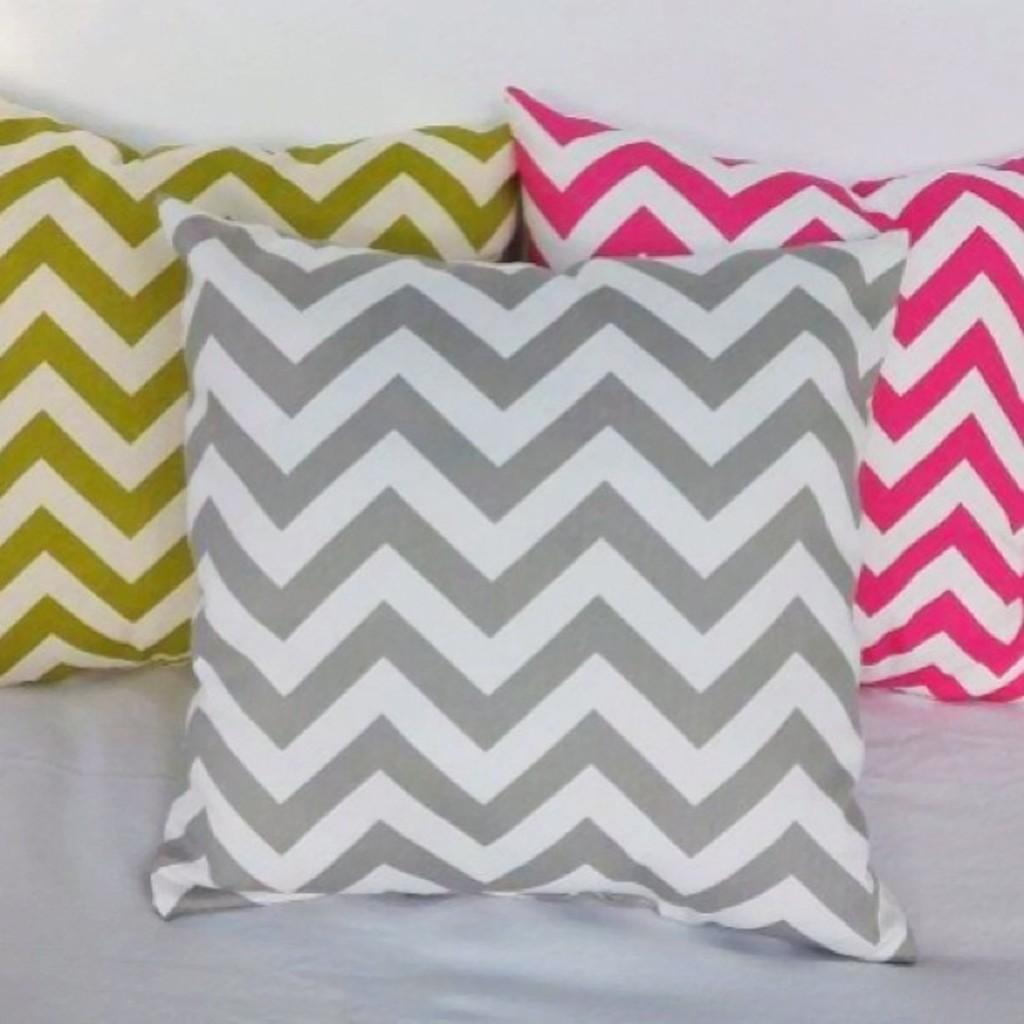How many pillows are visible in the image? There are three pillows in the image. Where are the pillows located? The pillows are on a surface. What can be observed about the appearance of the pillows? The pillows have designs. What is the color of the background in the image? The background of the image is white in color. What type of organization is responsible for the ornament on the pillows in the image? There is no specific organization mentioned in the image, and the pillows do not have an ornament. 